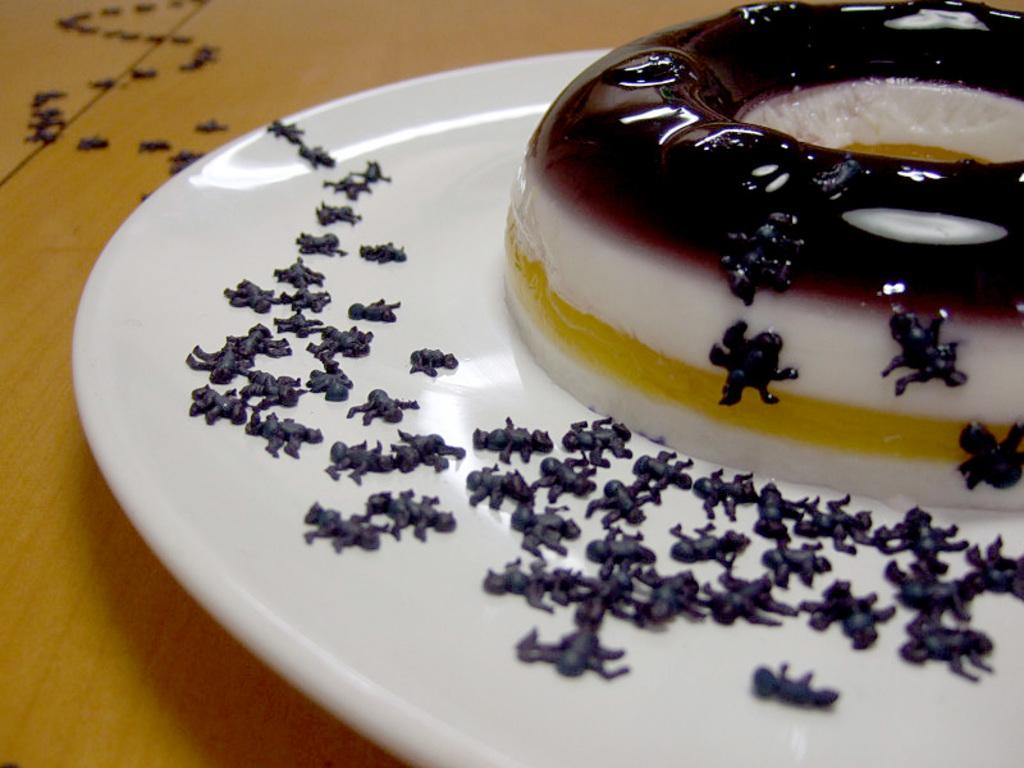What type of surface is present in the image? There is a wooden surface in the image. What is placed on the wooden surface? There is a white plate in the image. What can be seen on the white plate? There is food visible in the image. Can you tell me how many times the calculator is used in the image? There is no calculator present in the image, so it cannot be used or counted. 